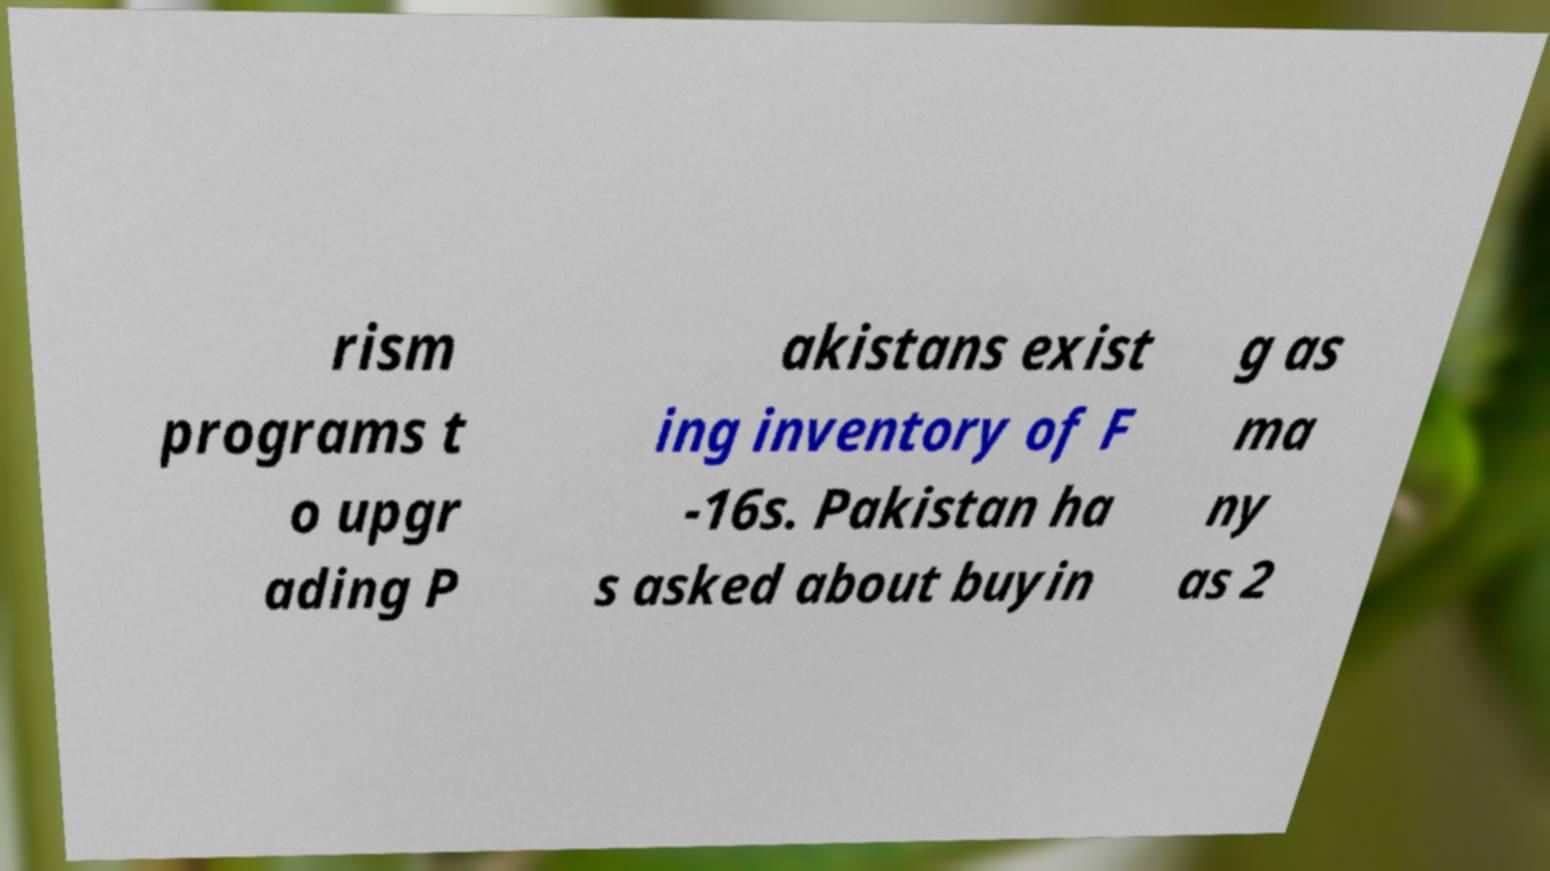Could you extract and type out the text from this image? rism programs t o upgr ading P akistans exist ing inventory of F -16s. Pakistan ha s asked about buyin g as ma ny as 2 